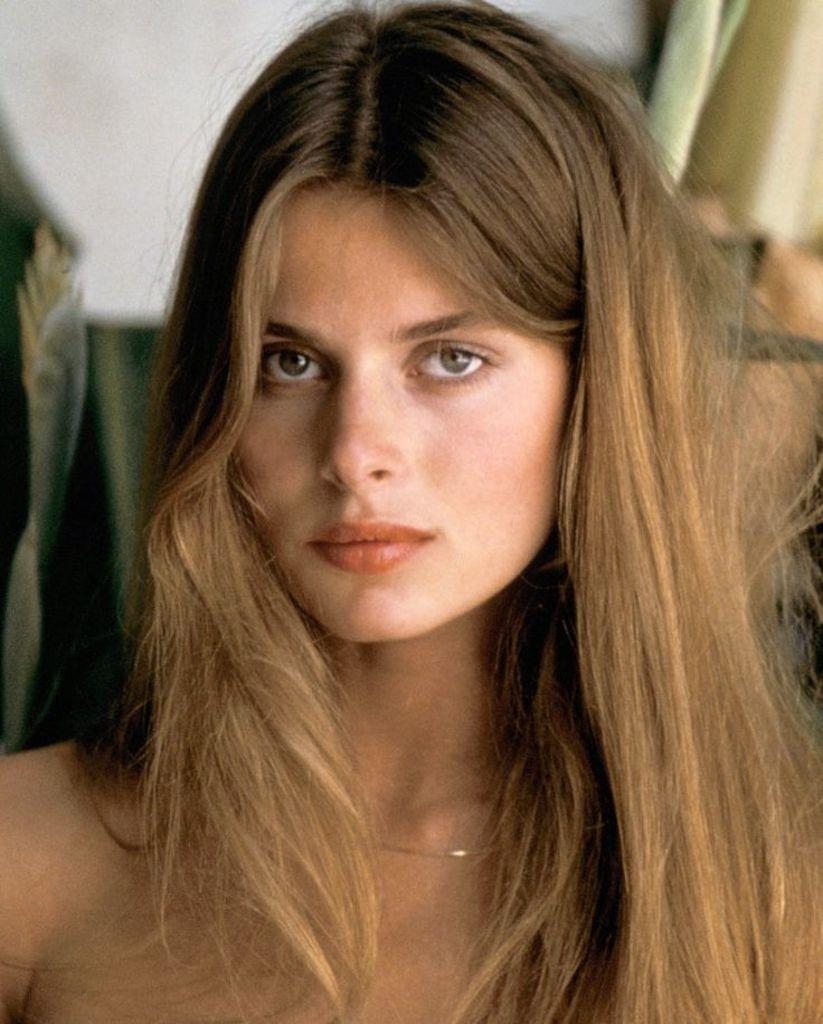What is the main subject in the foreground of the image? There is a woman in the foreground of the image. Can you describe the woman's hair in the image? The woman has loose hair in the image. What can be seen in the background of the image? There is a curtain in the background of the image. What type of brush is the woman using to clean her mind in the image? There is no brush or indication of the woman cleaning her mind in the image. 